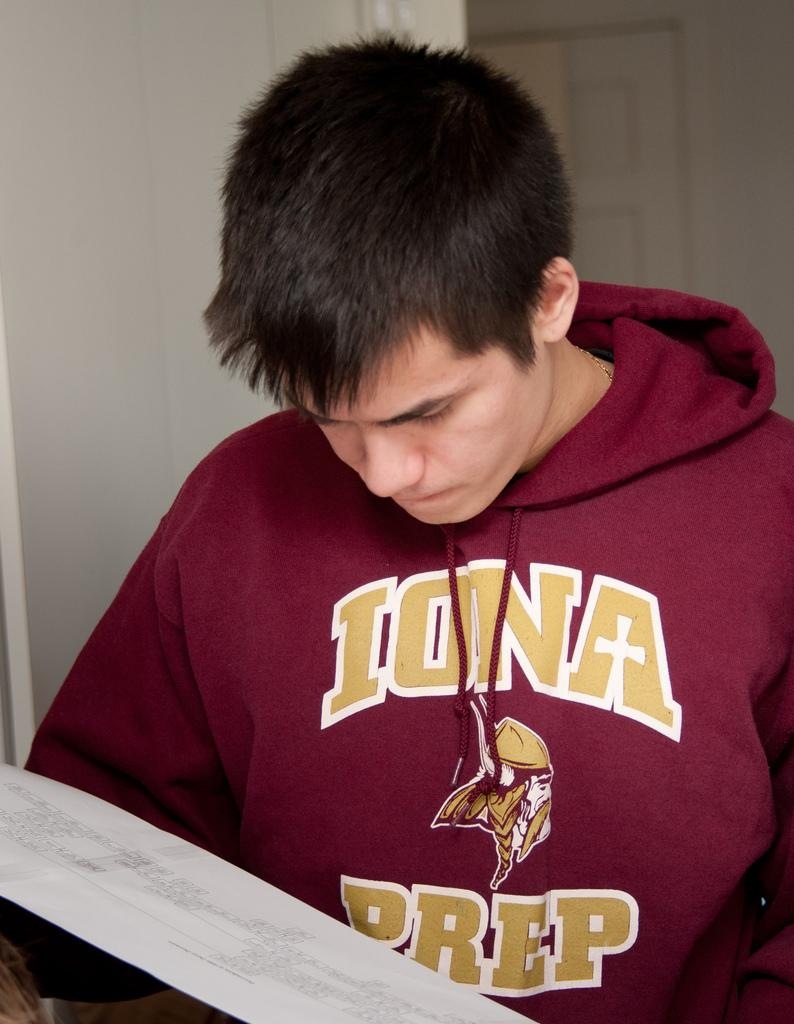<image>
Relay a brief, clear account of the picture shown. Boy wearing a red sweater that says Iowa Prep. 